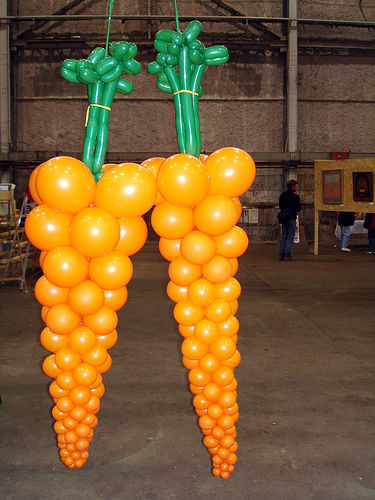<image>
Is there a balloon above the carrot? No. The balloon is not positioned above the carrot. The vertical arrangement shows a different relationship. Is the carrot on the painting? No. The carrot is not positioned on the painting. They may be near each other, but the carrot is not supported by or resting on top of the painting. 